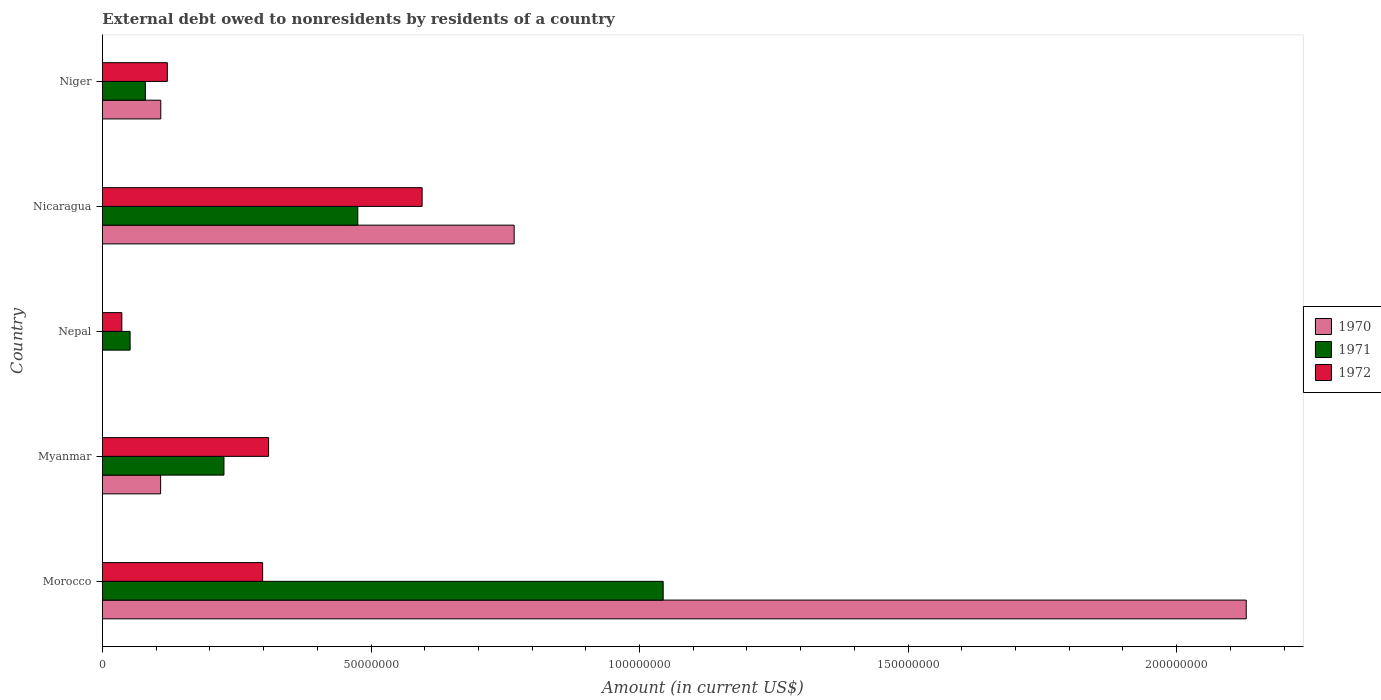Are the number of bars on each tick of the Y-axis equal?
Your answer should be compact. No. How many bars are there on the 2nd tick from the bottom?
Your answer should be compact. 3. What is the label of the 3rd group of bars from the top?
Make the answer very short. Nepal. In how many cases, is the number of bars for a given country not equal to the number of legend labels?
Give a very brief answer. 1. What is the external debt owed by residents in 1970 in Myanmar?
Offer a very short reply. 1.08e+07. Across all countries, what is the maximum external debt owed by residents in 1971?
Your answer should be compact. 1.04e+08. In which country was the external debt owed by residents in 1971 maximum?
Make the answer very short. Morocco. What is the total external debt owed by residents in 1970 in the graph?
Provide a succinct answer. 3.11e+08. What is the difference between the external debt owed by residents in 1972 in Myanmar and that in Nepal?
Keep it short and to the point. 2.73e+07. What is the difference between the external debt owed by residents in 1971 in Myanmar and the external debt owed by residents in 1972 in Morocco?
Keep it short and to the point. -7.20e+06. What is the average external debt owed by residents in 1970 per country?
Your answer should be compact. 6.23e+07. What is the difference between the external debt owed by residents in 1970 and external debt owed by residents in 1971 in Morocco?
Provide a succinct answer. 1.09e+08. What is the ratio of the external debt owed by residents in 1971 in Morocco to that in Niger?
Your answer should be very brief. 13.07. Is the difference between the external debt owed by residents in 1970 in Morocco and Myanmar greater than the difference between the external debt owed by residents in 1971 in Morocco and Myanmar?
Provide a short and direct response. Yes. What is the difference between the highest and the second highest external debt owed by residents in 1970?
Provide a succinct answer. 1.36e+08. What is the difference between the highest and the lowest external debt owed by residents in 1972?
Your response must be concise. 5.59e+07. Is the sum of the external debt owed by residents in 1972 in Myanmar and Nepal greater than the maximum external debt owed by residents in 1971 across all countries?
Offer a terse response. No. How many bars are there?
Offer a very short reply. 14. Are the values on the major ticks of X-axis written in scientific E-notation?
Ensure brevity in your answer.  No. Does the graph contain any zero values?
Ensure brevity in your answer.  Yes. Does the graph contain grids?
Your answer should be compact. No. Where does the legend appear in the graph?
Provide a succinct answer. Center right. How many legend labels are there?
Keep it short and to the point. 3. How are the legend labels stacked?
Keep it short and to the point. Vertical. What is the title of the graph?
Offer a terse response. External debt owed to nonresidents by residents of a country. What is the Amount (in current US$) of 1970 in Morocco?
Keep it short and to the point. 2.13e+08. What is the Amount (in current US$) in 1971 in Morocco?
Your answer should be compact. 1.04e+08. What is the Amount (in current US$) in 1972 in Morocco?
Offer a terse response. 2.98e+07. What is the Amount (in current US$) in 1970 in Myanmar?
Your response must be concise. 1.08e+07. What is the Amount (in current US$) in 1971 in Myanmar?
Your answer should be compact. 2.26e+07. What is the Amount (in current US$) of 1972 in Myanmar?
Give a very brief answer. 3.09e+07. What is the Amount (in current US$) in 1970 in Nepal?
Your answer should be very brief. 0. What is the Amount (in current US$) in 1971 in Nepal?
Your answer should be compact. 5.15e+06. What is the Amount (in current US$) of 1972 in Nepal?
Provide a succinct answer. 3.60e+06. What is the Amount (in current US$) in 1970 in Nicaragua?
Offer a very short reply. 7.67e+07. What is the Amount (in current US$) of 1971 in Nicaragua?
Your answer should be very brief. 4.75e+07. What is the Amount (in current US$) of 1972 in Nicaragua?
Offer a terse response. 5.95e+07. What is the Amount (in current US$) in 1970 in Niger?
Provide a succinct answer. 1.09e+07. What is the Amount (in current US$) of 1971 in Niger?
Keep it short and to the point. 7.98e+06. What is the Amount (in current US$) in 1972 in Niger?
Make the answer very short. 1.21e+07. Across all countries, what is the maximum Amount (in current US$) in 1970?
Your answer should be compact. 2.13e+08. Across all countries, what is the maximum Amount (in current US$) of 1971?
Give a very brief answer. 1.04e+08. Across all countries, what is the maximum Amount (in current US$) of 1972?
Give a very brief answer. 5.95e+07. Across all countries, what is the minimum Amount (in current US$) of 1971?
Your answer should be very brief. 5.15e+06. Across all countries, what is the minimum Amount (in current US$) of 1972?
Make the answer very short. 3.60e+06. What is the total Amount (in current US$) in 1970 in the graph?
Your response must be concise. 3.11e+08. What is the total Amount (in current US$) of 1971 in the graph?
Offer a very short reply. 1.88e+08. What is the total Amount (in current US$) in 1972 in the graph?
Provide a short and direct response. 1.36e+08. What is the difference between the Amount (in current US$) in 1970 in Morocco and that in Myanmar?
Keep it short and to the point. 2.02e+08. What is the difference between the Amount (in current US$) in 1971 in Morocco and that in Myanmar?
Provide a short and direct response. 8.18e+07. What is the difference between the Amount (in current US$) of 1972 in Morocco and that in Myanmar?
Give a very brief answer. -1.11e+06. What is the difference between the Amount (in current US$) of 1971 in Morocco and that in Nepal?
Your answer should be compact. 9.92e+07. What is the difference between the Amount (in current US$) of 1972 in Morocco and that in Nepal?
Your answer should be very brief. 2.62e+07. What is the difference between the Amount (in current US$) of 1970 in Morocco and that in Nicaragua?
Provide a short and direct response. 1.36e+08. What is the difference between the Amount (in current US$) in 1971 in Morocco and that in Nicaragua?
Your answer should be very brief. 5.69e+07. What is the difference between the Amount (in current US$) of 1972 in Morocco and that in Nicaragua?
Provide a short and direct response. -2.97e+07. What is the difference between the Amount (in current US$) in 1970 in Morocco and that in Niger?
Provide a succinct answer. 2.02e+08. What is the difference between the Amount (in current US$) in 1971 in Morocco and that in Niger?
Provide a short and direct response. 9.64e+07. What is the difference between the Amount (in current US$) in 1972 in Morocco and that in Niger?
Your answer should be very brief. 1.77e+07. What is the difference between the Amount (in current US$) of 1971 in Myanmar and that in Nepal?
Your answer should be very brief. 1.75e+07. What is the difference between the Amount (in current US$) of 1972 in Myanmar and that in Nepal?
Make the answer very short. 2.73e+07. What is the difference between the Amount (in current US$) of 1970 in Myanmar and that in Nicaragua?
Make the answer very short. -6.58e+07. What is the difference between the Amount (in current US$) of 1971 in Myanmar and that in Nicaragua?
Give a very brief answer. -2.49e+07. What is the difference between the Amount (in current US$) in 1972 in Myanmar and that in Nicaragua?
Your response must be concise. -2.86e+07. What is the difference between the Amount (in current US$) in 1970 in Myanmar and that in Niger?
Provide a short and direct response. -2.90e+04. What is the difference between the Amount (in current US$) of 1971 in Myanmar and that in Niger?
Offer a terse response. 1.46e+07. What is the difference between the Amount (in current US$) in 1972 in Myanmar and that in Niger?
Your response must be concise. 1.89e+07. What is the difference between the Amount (in current US$) of 1971 in Nepal and that in Nicaragua?
Your answer should be very brief. -4.24e+07. What is the difference between the Amount (in current US$) in 1972 in Nepal and that in Nicaragua?
Your answer should be compact. -5.59e+07. What is the difference between the Amount (in current US$) of 1971 in Nepal and that in Niger?
Give a very brief answer. -2.84e+06. What is the difference between the Amount (in current US$) of 1972 in Nepal and that in Niger?
Make the answer very short. -8.47e+06. What is the difference between the Amount (in current US$) in 1970 in Nicaragua and that in Niger?
Your answer should be very brief. 6.58e+07. What is the difference between the Amount (in current US$) in 1971 in Nicaragua and that in Niger?
Give a very brief answer. 3.96e+07. What is the difference between the Amount (in current US$) of 1972 in Nicaragua and that in Niger?
Provide a succinct answer. 4.74e+07. What is the difference between the Amount (in current US$) in 1970 in Morocco and the Amount (in current US$) in 1971 in Myanmar?
Provide a succinct answer. 1.90e+08. What is the difference between the Amount (in current US$) of 1970 in Morocco and the Amount (in current US$) of 1972 in Myanmar?
Ensure brevity in your answer.  1.82e+08. What is the difference between the Amount (in current US$) of 1971 in Morocco and the Amount (in current US$) of 1972 in Myanmar?
Offer a very short reply. 7.35e+07. What is the difference between the Amount (in current US$) of 1970 in Morocco and the Amount (in current US$) of 1971 in Nepal?
Ensure brevity in your answer.  2.08e+08. What is the difference between the Amount (in current US$) in 1970 in Morocco and the Amount (in current US$) in 1972 in Nepal?
Ensure brevity in your answer.  2.09e+08. What is the difference between the Amount (in current US$) of 1971 in Morocco and the Amount (in current US$) of 1972 in Nepal?
Provide a short and direct response. 1.01e+08. What is the difference between the Amount (in current US$) in 1970 in Morocco and the Amount (in current US$) in 1971 in Nicaragua?
Offer a very short reply. 1.65e+08. What is the difference between the Amount (in current US$) of 1970 in Morocco and the Amount (in current US$) of 1972 in Nicaragua?
Ensure brevity in your answer.  1.53e+08. What is the difference between the Amount (in current US$) of 1971 in Morocco and the Amount (in current US$) of 1972 in Nicaragua?
Provide a succinct answer. 4.49e+07. What is the difference between the Amount (in current US$) of 1970 in Morocco and the Amount (in current US$) of 1971 in Niger?
Your answer should be compact. 2.05e+08. What is the difference between the Amount (in current US$) of 1970 in Morocco and the Amount (in current US$) of 1972 in Niger?
Your response must be concise. 2.01e+08. What is the difference between the Amount (in current US$) in 1971 in Morocco and the Amount (in current US$) in 1972 in Niger?
Your answer should be compact. 9.23e+07. What is the difference between the Amount (in current US$) of 1970 in Myanmar and the Amount (in current US$) of 1971 in Nepal?
Your answer should be very brief. 5.68e+06. What is the difference between the Amount (in current US$) in 1970 in Myanmar and the Amount (in current US$) in 1972 in Nepal?
Make the answer very short. 7.22e+06. What is the difference between the Amount (in current US$) in 1971 in Myanmar and the Amount (in current US$) in 1972 in Nepal?
Your response must be concise. 1.90e+07. What is the difference between the Amount (in current US$) in 1970 in Myanmar and the Amount (in current US$) in 1971 in Nicaragua?
Make the answer very short. -3.67e+07. What is the difference between the Amount (in current US$) of 1970 in Myanmar and the Amount (in current US$) of 1972 in Nicaragua?
Offer a terse response. -4.87e+07. What is the difference between the Amount (in current US$) of 1971 in Myanmar and the Amount (in current US$) of 1972 in Nicaragua?
Provide a succinct answer. -3.69e+07. What is the difference between the Amount (in current US$) of 1970 in Myanmar and the Amount (in current US$) of 1971 in Niger?
Offer a very short reply. 2.84e+06. What is the difference between the Amount (in current US$) in 1970 in Myanmar and the Amount (in current US$) in 1972 in Niger?
Provide a succinct answer. -1.25e+06. What is the difference between the Amount (in current US$) of 1971 in Myanmar and the Amount (in current US$) of 1972 in Niger?
Ensure brevity in your answer.  1.05e+07. What is the difference between the Amount (in current US$) of 1971 in Nepal and the Amount (in current US$) of 1972 in Nicaragua?
Provide a short and direct response. -5.44e+07. What is the difference between the Amount (in current US$) of 1971 in Nepal and the Amount (in current US$) of 1972 in Niger?
Offer a very short reply. -6.93e+06. What is the difference between the Amount (in current US$) of 1970 in Nicaragua and the Amount (in current US$) of 1971 in Niger?
Your answer should be compact. 6.87e+07. What is the difference between the Amount (in current US$) in 1970 in Nicaragua and the Amount (in current US$) in 1972 in Niger?
Your answer should be compact. 6.46e+07. What is the difference between the Amount (in current US$) of 1971 in Nicaragua and the Amount (in current US$) of 1972 in Niger?
Your response must be concise. 3.55e+07. What is the average Amount (in current US$) in 1970 per country?
Ensure brevity in your answer.  6.23e+07. What is the average Amount (in current US$) of 1971 per country?
Give a very brief answer. 3.75e+07. What is the average Amount (in current US$) of 1972 per country?
Provide a succinct answer. 2.72e+07. What is the difference between the Amount (in current US$) in 1970 and Amount (in current US$) in 1971 in Morocco?
Provide a short and direct response. 1.09e+08. What is the difference between the Amount (in current US$) in 1970 and Amount (in current US$) in 1972 in Morocco?
Your answer should be very brief. 1.83e+08. What is the difference between the Amount (in current US$) of 1971 and Amount (in current US$) of 1972 in Morocco?
Your response must be concise. 7.46e+07. What is the difference between the Amount (in current US$) of 1970 and Amount (in current US$) of 1971 in Myanmar?
Offer a very short reply. -1.18e+07. What is the difference between the Amount (in current US$) in 1970 and Amount (in current US$) in 1972 in Myanmar?
Offer a very short reply. -2.01e+07. What is the difference between the Amount (in current US$) of 1971 and Amount (in current US$) of 1972 in Myanmar?
Offer a terse response. -8.31e+06. What is the difference between the Amount (in current US$) in 1971 and Amount (in current US$) in 1972 in Nepal?
Give a very brief answer. 1.54e+06. What is the difference between the Amount (in current US$) of 1970 and Amount (in current US$) of 1971 in Nicaragua?
Your answer should be very brief. 2.91e+07. What is the difference between the Amount (in current US$) in 1970 and Amount (in current US$) in 1972 in Nicaragua?
Ensure brevity in your answer.  1.71e+07. What is the difference between the Amount (in current US$) of 1971 and Amount (in current US$) of 1972 in Nicaragua?
Provide a succinct answer. -1.20e+07. What is the difference between the Amount (in current US$) in 1970 and Amount (in current US$) in 1971 in Niger?
Provide a short and direct response. 2.87e+06. What is the difference between the Amount (in current US$) in 1970 and Amount (in current US$) in 1972 in Niger?
Provide a succinct answer. -1.22e+06. What is the difference between the Amount (in current US$) in 1971 and Amount (in current US$) in 1972 in Niger?
Make the answer very short. -4.09e+06. What is the ratio of the Amount (in current US$) of 1970 in Morocco to that in Myanmar?
Your response must be concise. 19.67. What is the ratio of the Amount (in current US$) in 1971 in Morocco to that in Myanmar?
Give a very brief answer. 4.62. What is the ratio of the Amount (in current US$) of 1972 in Morocco to that in Myanmar?
Keep it short and to the point. 0.96. What is the ratio of the Amount (in current US$) in 1971 in Morocco to that in Nepal?
Provide a succinct answer. 20.28. What is the ratio of the Amount (in current US$) of 1972 in Morocco to that in Nepal?
Provide a succinct answer. 8.27. What is the ratio of the Amount (in current US$) of 1970 in Morocco to that in Nicaragua?
Provide a short and direct response. 2.78. What is the ratio of the Amount (in current US$) in 1971 in Morocco to that in Nicaragua?
Provide a succinct answer. 2.2. What is the ratio of the Amount (in current US$) of 1972 in Morocco to that in Nicaragua?
Offer a terse response. 0.5. What is the ratio of the Amount (in current US$) of 1970 in Morocco to that in Niger?
Provide a short and direct response. 19.61. What is the ratio of the Amount (in current US$) of 1971 in Morocco to that in Niger?
Give a very brief answer. 13.07. What is the ratio of the Amount (in current US$) in 1972 in Morocco to that in Niger?
Keep it short and to the point. 2.47. What is the ratio of the Amount (in current US$) in 1971 in Myanmar to that in Nepal?
Keep it short and to the point. 4.39. What is the ratio of the Amount (in current US$) in 1972 in Myanmar to that in Nepal?
Your answer should be compact. 8.58. What is the ratio of the Amount (in current US$) in 1970 in Myanmar to that in Nicaragua?
Provide a short and direct response. 0.14. What is the ratio of the Amount (in current US$) of 1971 in Myanmar to that in Nicaragua?
Ensure brevity in your answer.  0.48. What is the ratio of the Amount (in current US$) in 1972 in Myanmar to that in Nicaragua?
Give a very brief answer. 0.52. What is the ratio of the Amount (in current US$) of 1970 in Myanmar to that in Niger?
Your answer should be compact. 1. What is the ratio of the Amount (in current US$) in 1971 in Myanmar to that in Niger?
Ensure brevity in your answer.  2.83. What is the ratio of the Amount (in current US$) of 1972 in Myanmar to that in Niger?
Offer a terse response. 2.56. What is the ratio of the Amount (in current US$) of 1971 in Nepal to that in Nicaragua?
Your answer should be compact. 0.11. What is the ratio of the Amount (in current US$) of 1972 in Nepal to that in Nicaragua?
Provide a succinct answer. 0.06. What is the ratio of the Amount (in current US$) in 1971 in Nepal to that in Niger?
Keep it short and to the point. 0.64. What is the ratio of the Amount (in current US$) of 1972 in Nepal to that in Niger?
Keep it short and to the point. 0.3. What is the ratio of the Amount (in current US$) in 1970 in Nicaragua to that in Niger?
Your answer should be very brief. 7.06. What is the ratio of the Amount (in current US$) in 1971 in Nicaragua to that in Niger?
Your answer should be compact. 5.95. What is the ratio of the Amount (in current US$) in 1972 in Nicaragua to that in Niger?
Offer a terse response. 4.93. What is the difference between the highest and the second highest Amount (in current US$) of 1970?
Your answer should be very brief. 1.36e+08. What is the difference between the highest and the second highest Amount (in current US$) in 1971?
Keep it short and to the point. 5.69e+07. What is the difference between the highest and the second highest Amount (in current US$) in 1972?
Your answer should be very brief. 2.86e+07. What is the difference between the highest and the lowest Amount (in current US$) of 1970?
Offer a terse response. 2.13e+08. What is the difference between the highest and the lowest Amount (in current US$) in 1971?
Your answer should be very brief. 9.92e+07. What is the difference between the highest and the lowest Amount (in current US$) of 1972?
Ensure brevity in your answer.  5.59e+07. 